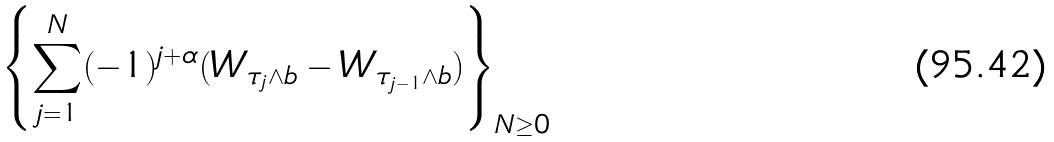<formula> <loc_0><loc_0><loc_500><loc_500>\left \{ \sum _ { j = 1 } ^ { N } ( - 1 ) ^ { j + \alpha } ( W _ { \tau _ { j } \wedge b } - W _ { \tau _ { j - 1 } \wedge b } ) \right \} _ { N \geq 0 }</formula> 